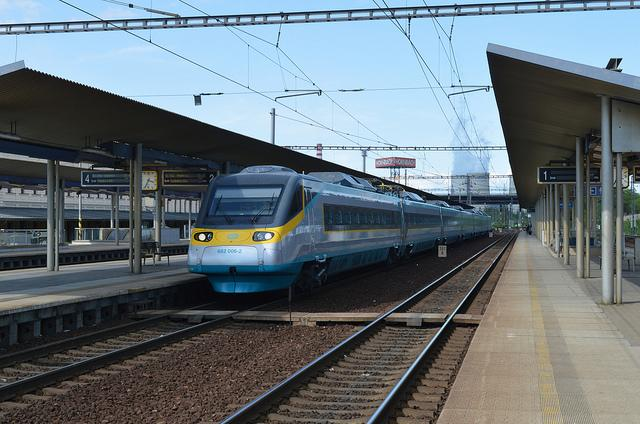What is the item closest to the green sign on the left that has the number 4 on it? Please explain your reasoning. clock. The clock is near the sign with the four on it. 